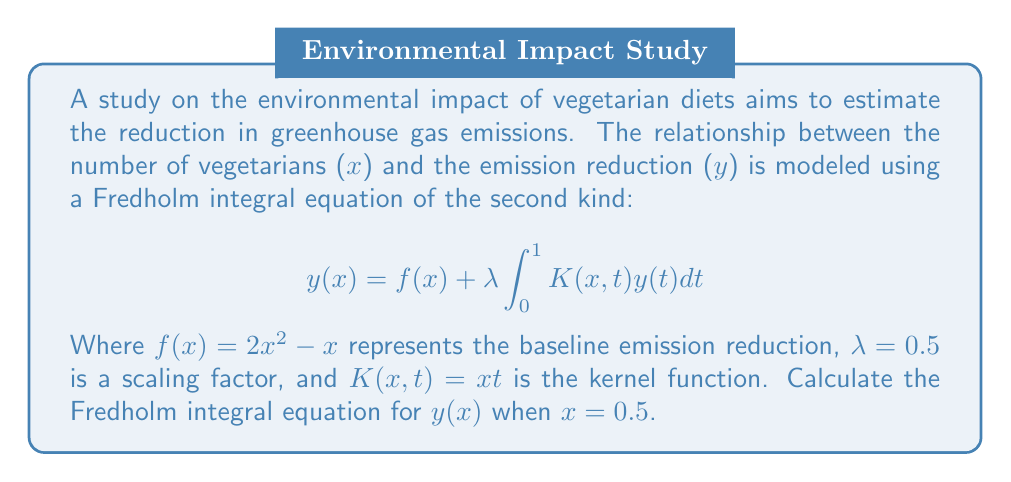Help me with this question. To solve this problem, we'll follow these steps:

1) Start with the given Fredholm integral equation:
   $$y(x) = f(x) + \lambda \int_0^1 K(x,t)y(t)dt$$

2) Substitute the given values:
   $f(x) = 2x^2 - x$
   $\lambda = 0.5$
   $K(x,t) = xt$
   $x = 0.5$

3) Calculate $f(0.5)$:
   $f(0.5) = 2(0.5)^2 - 0.5 = 0.5 - 0.5 = 0$

4) Substitute these into the equation:
   $$y(0.5) = 0 + 0.5 \int_0^1 (0.5t)y(t)dt$$

5) Simplify:
   $$y(0.5) = 0.25 \int_0^1 ty(t)dt$$

This is the Fredholm integral equation for $y(x)$ when $x = 0.5$.
Answer: $$y(0.5) = 0.25 \int_0^1 ty(t)dt$$ 